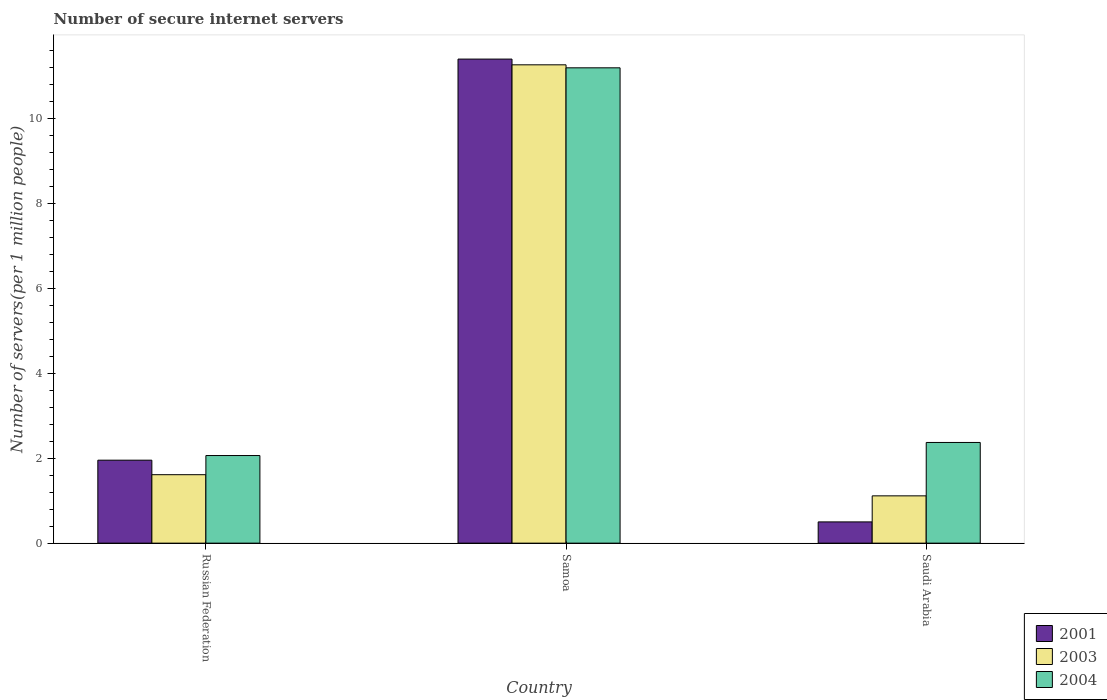How many different coloured bars are there?
Ensure brevity in your answer.  3. How many groups of bars are there?
Your answer should be compact. 3. Are the number of bars per tick equal to the number of legend labels?
Provide a short and direct response. Yes. Are the number of bars on each tick of the X-axis equal?
Your answer should be compact. Yes. How many bars are there on the 2nd tick from the right?
Provide a short and direct response. 3. What is the label of the 2nd group of bars from the left?
Your answer should be compact. Samoa. What is the number of secure internet servers in 2003 in Russian Federation?
Your answer should be very brief. 1.61. Across all countries, what is the maximum number of secure internet servers in 2004?
Give a very brief answer. 11.19. Across all countries, what is the minimum number of secure internet servers in 2001?
Your answer should be very brief. 0.5. In which country was the number of secure internet servers in 2004 maximum?
Provide a succinct answer. Samoa. In which country was the number of secure internet servers in 2003 minimum?
Offer a terse response. Saudi Arabia. What is the total number of secure internet servers in 2001 in the graph?
Provide a short and direct response. 13.84. What is the difference between the number of secure internet servers in 2003 in Russian Federation and that in Samoa?
Your response must be concise. -9.65. What is the difference between the number of secure internet servers in 2001 in Saudi Arabia and the number of secure internet servers in 2004 in Russian Federation?
Your response must be concise. -1.56. What is the average number of secure internet servers in 2004 per country?
Keep it short and to the point. 5.21. What is the difference between the number of secure internet servers of/in 2003 and number of secure internet servers of/in 2004 in Russian Federation?
Provide a succinct answer. -0.45. What is the ratio of the number of secure internet servers in 2001 in Russian Federation to that in Samoa?
Make the answer very short. 0.17. What is the difference between the highest and the second highest number of secure internet servers in 2001?
Your response must be concise. -1.45. What is the difference between the highest and the lowest number of secure internet servers in 2001?
Your answer should be very brief. 10.89. In how many countries, is the number of secure internet servers in 2003 greater than the average number of secure internet servers in 2003 taken over all countries?
Provide a short and direct response. 1. Is the sum of the number of secure internet servers in 2003 in Russian Federation and Samoa greater than the maximum number of secure internet servers in 2001 across all countries?
Provide a succinct answer. Yes. What does the 2nd bar from the left in Saudi Arabia represents?
Your answer should be compact. 2003. Is it the case that in every country, the sum of the number of secure internet servers in 2004 and number of secure internet servers in 2001 is greater than the number of secure internet servers in 2003?
Your answer should be compact. Yes. How many bars are there?
Offer a terse response. 9. Are all the bars in the graph horizontal?
Offer a very short reply. No. What is the difference between two consecutive major ticks on the Y-axis?
Your response must be concise. 2. Where does the legend appear in the graph?
Ensure brevity in your answer.  Bottom right. How many legend labels are there?
Offer a very short reply. 3. How are the legend labels stacked?
Give a very brief answer. Vertical. What is the title of the graph?
Your answer should be compact. Number of secure internet servers. Does "1993" appear as one of the legend labels in the graph?
Ensure brevity in your answer.  No. What is the label or title of the X-axis?
Offer a terse response. Country. What is the label or title of the Y-axis?
Offer a terse response. Number of servers(per 1 million people). What is the Number of servers(per 1 million people) in 2001 in Russian Federation?
Provide a succinct answer. 1.95. What is the Number of servers(per 1 million people) in 2003 in Russian Federation?
Give a very brief answer. 1.61. What is the Number of servers(per 1 million people) of 2004 in Russian Federation?
Keep it short and to the point. 2.06. What is the Number of servers(per 1 million people) in 2001 in Samoa?
Provide a succinct answer. 11.39. What is the Number of servers(per 1 million people) in 2003 in Samoa?
Your answer should be compact. 11.26. What is the Number of servers(per 1 million people) in 2004 in Samoa?
Offer a very short reply. 11.19. What is the Number of servers(per 1 million people) of 2001 in Saudi Arabia?
Your response must be concise. 0.5. What is the Number of servers(per 1 million people) in 2003 in Saudi Arabia?
Give a very brief answer. 1.11. What is the Number of servers(per 1 million people) of 2004 in Saudi Arabia?
Ensure brevity in your answer.  2.37. Across all countries, what is the maximum Number of servers(per 1 million people) of 2001?
Keep it short and to the point. 11.39. Across all countries, what is the maximum Number of servers(per 1 million people) in 2003?
Provide a succinct answer. 11.26. Across all countries, what is the maximum Number of servers(per 1 million people) of 2004?
Your answer should be very brief. 11.19. Across all countries, what is the minimum Number of servers(per 1 million people) of 2001?
Give a very brief answer. 0.5. Across all countries, what is the minimum Number of servers(per 1 million people) in 2003?
Keep it short and to the point. 1.11. Across all countries, what is the minimum Number of servers(per 1 million people) in 2004?
Your answer should be compact. 2.06. What is the total Number of servers(per 1 million people) of 2001 in the graph?
Make the answer very short. 13.84. What is the total Number of servers(per 1 million people) of 2003 in the graph?
Provide a succinct answer. 13.98. What is the total Number of servers(per 1 million people) in 2004 in the graph?
Provide a succinct answer. 15.62. What is the difference between the Number of servers(per 1 million people) of 2001 in Russian Federation and that in Samoa?
Ensure brevity in your answer.  -9.44. What is the difference between the Number of servers(per 1 million people) in 2003 in Russian Federation and that in Samoa?
Your answer should be compact. -9.65. What is the difference between the Number of servers(per 1 million people) of 2004 in Russian Federation and that in Samoa?
Your answer should be very brief. -9.12. What is the difference between the Number of servers(per 1 million people) in 2001 in Russian Federation and that in Saudi Arabia?
Give a very brief answer. 1.45. What is the difference between the Number of servers(per 1 million people) in 2003 in Russian Federation and that in Saudi Arabia?
Provide a short and direct response. 0.5. What is the difference between the Number of servers(per 1 million people) in 2004 in Russian Federation and that in Saudi Arabia?
Ensure brevity in your answer.  -0.31. What is the difference between the Number of servers(per 1 million people) of 2001 in Samoa and that in Saudi Arabia?
Your answer should be compact. 10.89. What is the difference between the Number of servers(per 1 million people) in 2003 in Samoa and that in Saudi Arabia?
Ensure brevity in your answer.  10.14. What is the difference between the Number of servers(per 1 million people) of 2004 in Samoa and that in Saudi Arabia?
Make the answer very short. 8.82. What is the difference between the Number of servers(per 1 million people) of 2001 in Russian Federation and the Number of servers(per 1 million people) of 2003 in Samoa?
Offer a very short reply. -9.3. What is the difference between the Number of servers(per 1 million people) in 2001 in Russian Federation and the Number of servers(per 1 million people) in 2004 in Samoa?
Your answer should be very brief. -9.23. What is the difference between the Number of servers(per 1 million people) in 2003 in Russian Federation and the Number of servers(per 1 million people) in 2004 in Samoa?
Your answer should be very brief. -9.58. What is the difference between the Number of servers(per 1 million people) in 2001 in Russian Federation and the Number of servers(per 1 million people) in 2003 in Saudi Arabia?
Offer a very short reply. 0.84. What is the difference between the Number of servers(per 1 million people) in 2001 in Russian Federation and the Number of servers(per 1 million people) in 2004 in Saudi Arabia?
Keep it short and to the point. -0.42. What is the difference between the Number of servers(per 1 million people) in 2003 in Russian Federation and the Number of servers(per 1 million people) in 2004 in Saudi Arabia?
Give a very brief answer. -0.76. What is the difference between the Number of servers(per 1 million people) in 2001 in Samoa and the Number of servers(per 1 million people) in 2003 in Saudi Arabia?
Provide a short and direct response. 10.28. What is the difference between the Number of servers(per 1 million people) of 2001 in Samoa and the Number of servers(per 1 million people) of 2004 in Saudi Arabia?
Your response must be concise. 9.02. What is the difference between the Number of servers(per 1 million people) of 2003 in Samoa and the Number of servers(per 1 million people) of 2004 in Saudi Arabia?
Provide a succinct answer. 8.89. What is the average Number of servers(per 1 million people) in 2001 per country?
Keep it short and to the point. 4.61. What is the average Number of servers(per 1 million people) of 2003 per country?
Your answer should be compact. 4.66. What is the average Number of servers(per 1 million people) in 2004 per country?
Your answer should be compact. 5.21. What is the difference between the Number of servers(per 1 million people) of 2001 and Number of servers(per 1 million people) of 2003 in Russian Federation?
Keep it short and to the point. 0.34. What is the difference between the Number of servers(per 1 million people) in 2001 and Number of servers(per 1 million people) in 2004 in Russian Federation?
Provide a succinct answer. -0.11. What is the difference between the Number of servers(per 1 million people) in 2003 and Number of servers(per 1 million people) in 2004 in Russian Federation?
Give a very brief answer. -0.45. What is the difference between the Number of servers(per 1 million people) of 2001 and Number of servers(per 1 million people) of 2003 in Samoa?
Your answer should be compact. 0.14. What is the difference between the Number of servers(per 1 million people) of 2001 and Number of servers(per 1 million people) of 2004 in Samoa?
Make the answer very short. 0.21. What is the difference between the Number of servers(per 1 million people) of 2003 and Number of servers(per 1 million people) of 2004 in Samoa?
Provide a short and direct response. 0.07. What is the difference between the Number of servers(per 1 million people) of 2001 and Number of servers(per 1 million people) of 2003 in Saudi Arabia?
Keep it short and to the point. -0.61. What is the difference between the Number of servers(per 1 million people) in 2001 and Number of servers(per 1 million people) in 2004 in Saudi Arabia?
Your response must be concise. -1.87. What is the difference between the Number of servers(per 1 million people) in 2003 and Number of servers(per 1 million people) in 2004 in Saudi Arabia?
Give a very brief answer. -1.26. What is the ratio of the Number of servers(per 1 million people) of 2001 in Russian Federation to that in Samoa?
Offer a terse response. 0.17. What is the ratio of the Number of servers(per 1 million people) of 2003 in Russian Federation to that in Samoa?
Your answer should be compact. 0.14. What is the ratio of the Number of servers(per 1 million people) of 2004 in Russian Federation to that in Samoa?
Your response must be concise. 0.18. What is the ratio of the Number of servers(per 1 million people) of 2001 in Russian Federation to that in Saudi Arabia?
Your answer should be compact. 3.91. What is the ratio of the Number of servers(per 1 million people) in 2003 in Russian Federation to that in Saudi Arabia?
Your answer should be very brief. 1.45. What is the ratio of the Number of servers(per 1 million people) in 2004 in Russian Federation to that in Saudi Arabia?
Offer a terse response. 0.87. What is the ratio of the Number of servers(per 1 million people) in 2001 in Samoa to that in Saudi Arabia?
Offer a terse response. 22.79. What is the ratio of the Number of servers(per 1 million people) of 2003 in Samoa to that in Saudi Arabia?
Give a very brief answer. 10.11. What is the ratio of the Number of servers(per 1 million people) of 2004 in Samoa to that in Saudi Arabia?
Keep it short and to the point. 4.72. What is the difference between the highest and the second highest Number of servers(per 1 million people) of 2001?
Ensure brevity in your answer.  9.44. What is the difference between the highest and the second highest Number of servers(per 1 million people) in 2003?
Ensure brevity in your answer.  9.65. What is the difference between the highest and the second highest Number of servers(per 1 million people) of 2004?
Give a very brief answer. 8.82. What is the difference between the highest and the lowest Number of servers(per 1 million people) in 2001?
Your answer should be compact. 10.89. What is the difference between the highest and the lowest Number of servers(per 1 million people) of 2003?
Provide a short and direct response. 10.14. What is the difference between the highest and the lowest Number of servers(per 1 million people) of 2004?
Make the answer very short. 9.12. 